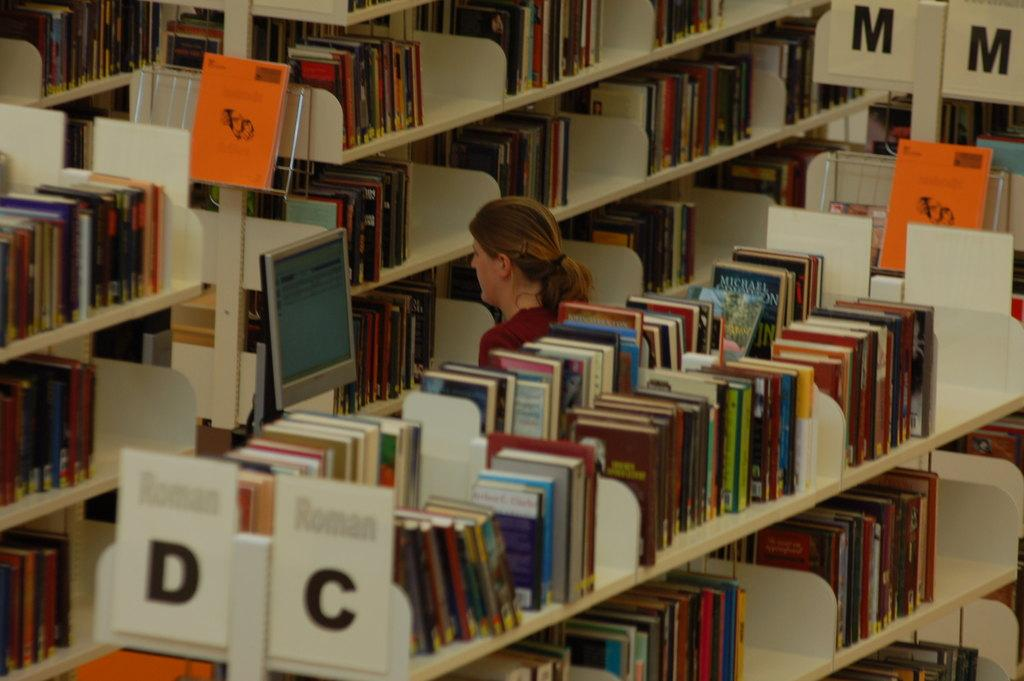<image>
Describe the image concisely. Rows of books on display with D, C, M, M heading the shelves. 